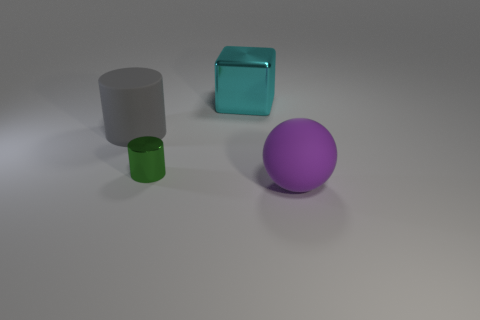Add 2 big gray matte objects. How many objects exist? 6 Subtract all cubes. How many objects are left? 3 Add 2 large metallic objects. How many large metallic objects exist? 3 Subtract 0 cyan spheres. How many objects are left? 4 Subtract all purple objects. Subtract all rubber spheres. How many objects are left? 2 Add 4 big gray cylinders. How many big gray cylinders are left? 5 